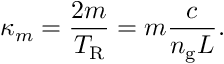<formula> <loc_0><loc_0><loc_500><loc_500>\kappa _ { m } = \frac { 2 m } { T _ { R } } = m \frac { c } { n _ { g } L } .</formula> 